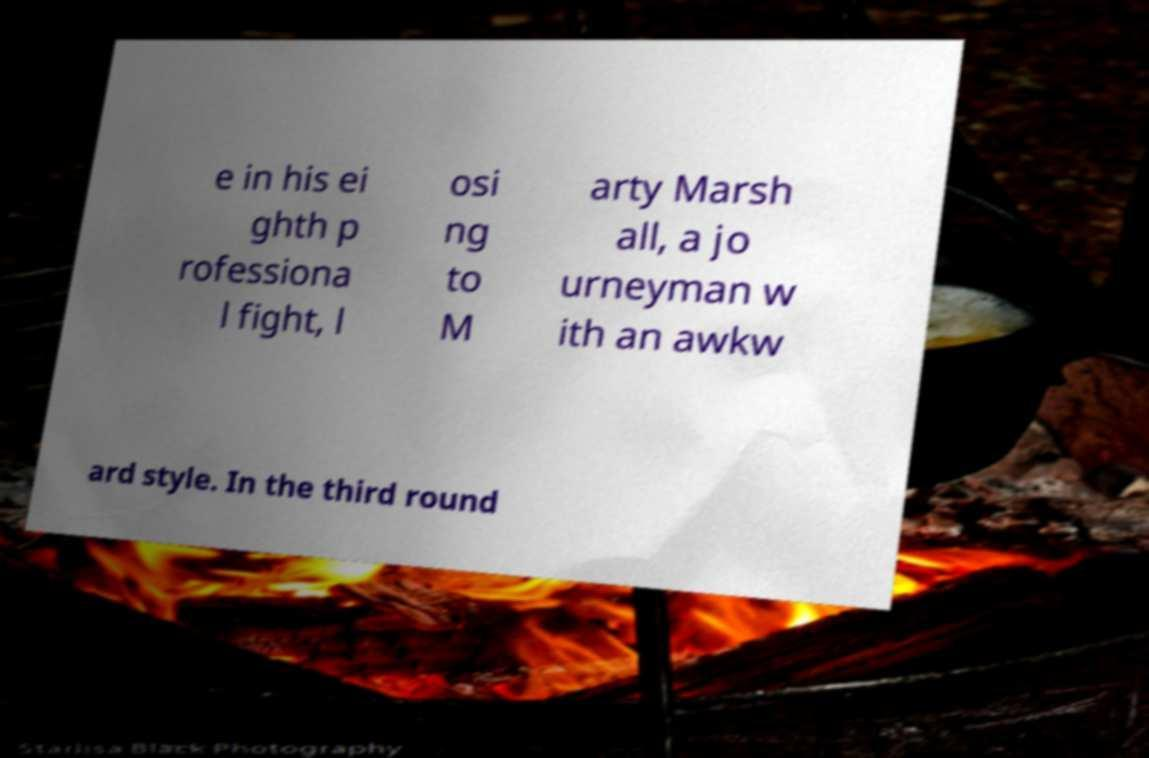Can you accurately transcribe the text from the provided image for me? e in his ei ghth p rofessiona l fight, l osi ng to M arty Marsh all, a jo urneyman w ith an awkw ard style. In the third round 